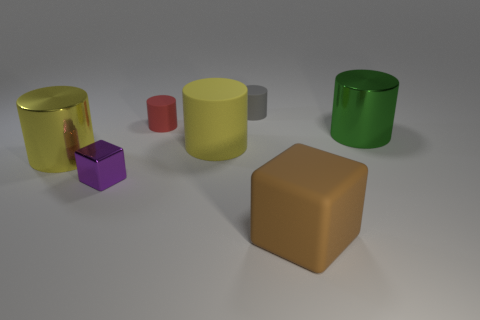Subtract all big green shiny cylinders. How many cylinders are left? 4 Subtract all red blocks. How many yellow cylinders are left? 2 Add 1 large cylinders. How many objects exist? 8 Subtract all brown blocks. How many blocks are left? 1 Subtract all cylinders. How many objects are left? 2 Subtract all purple cylinders. Subtract all blue balls. How many cylinders are left? 5 Subtract all green metallic things. Subtract all green metal cylinders. How many objects are left? 5 Add 7 large rubber blocks. How many large rubber blocks are left? 8 Add 6 large cylinders. How many large cylinders exist? 9 Subtract 0 cyan cylinders. How many objects are left? 7 